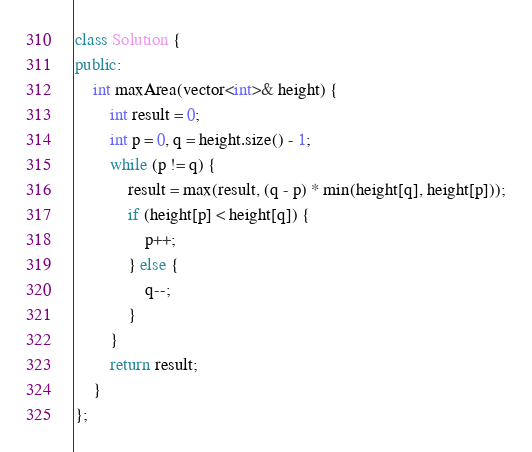<code> <loc_0><loc_0><loc_500><loc_500><_C++_>class Solution {
public:
    int maxArea(vector<int>& height) {
        int result = 0;
        int p = 0, q = height.size() - 1;
        while (p != q) {
            result = max(result, (q - p) * min(height[q], height[p]));
            if (height[p] < height[q]) {
                p++;
            } else {
                q--;
            }
        }
        return result;
    }
};</code> 